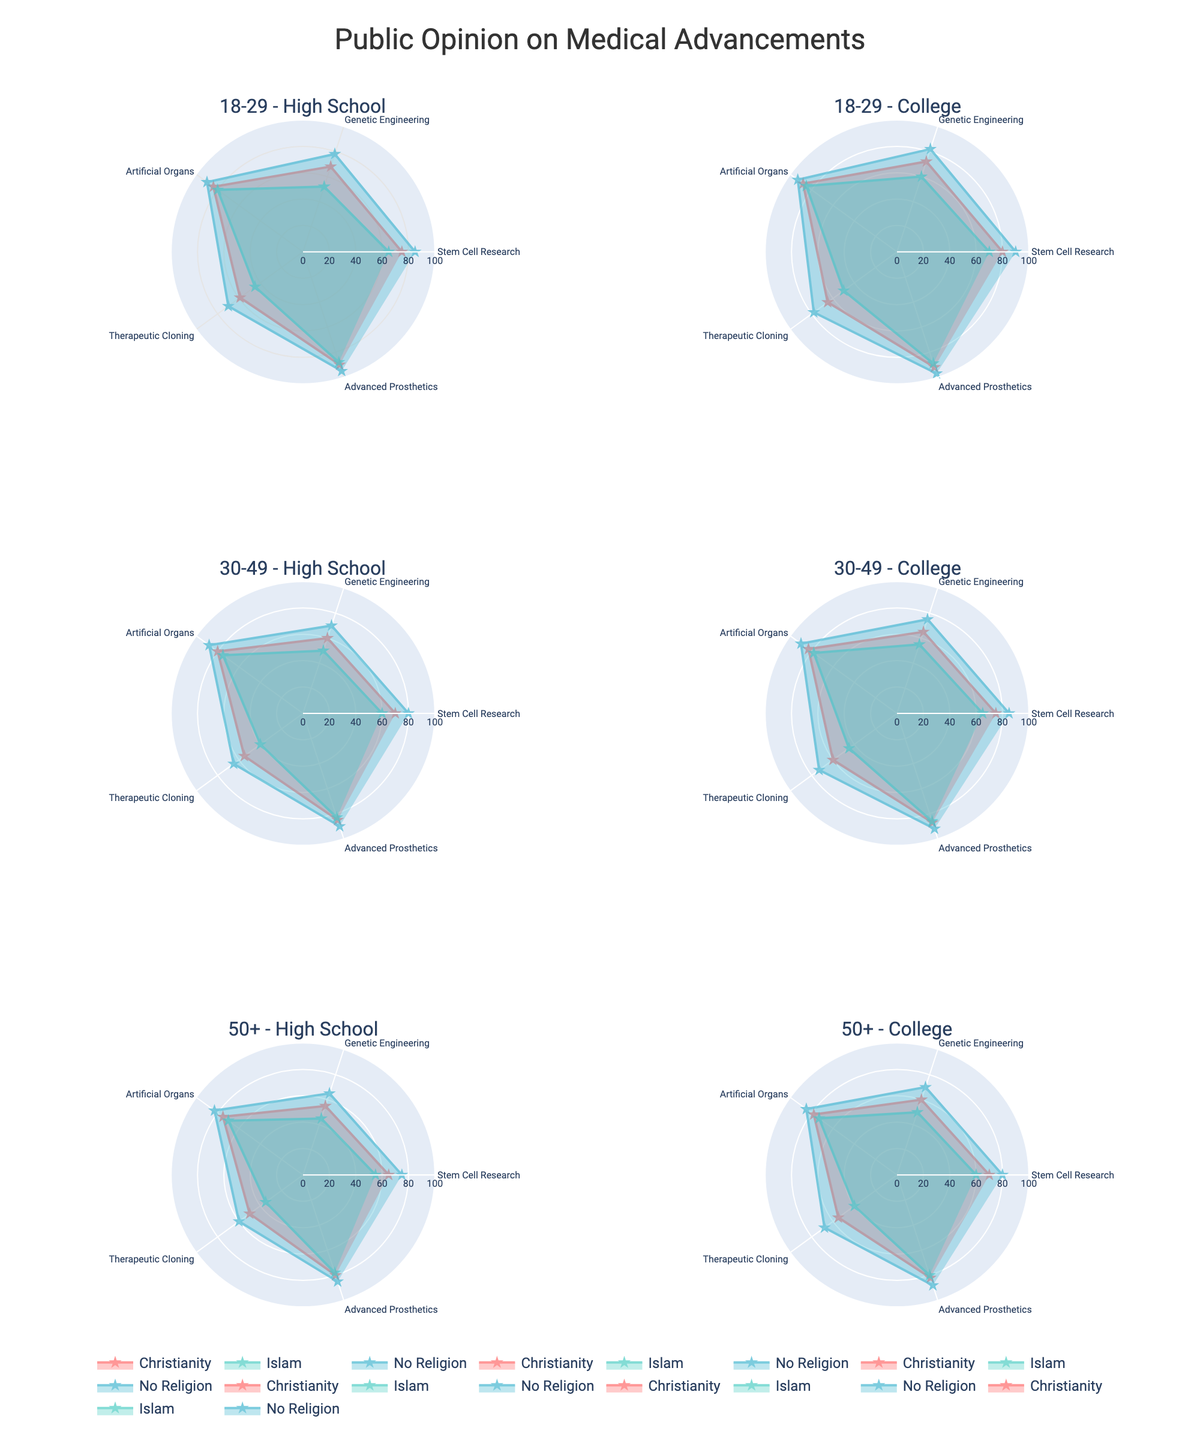Which age group and education level combination shows the highest support for advanced prosthetics across all religious beliefs? To determine this, look for the subplot with the largest values for advanced prosthetics in all religious belief categories. The subplot for the 18-29 age group with a college education shows the highest composite values across Christianity, Islam, and No Religion, indicating the highest support.
Answer: 18-29, College Which religious belief group consistently has the lowest support for therapeutic cloning across different age and education groups? Examine each subplot for therapeutic cloning support and identify which religious belief group has the lowest values. Across all subplots, the Islamic group consistently has the lowest support for therapeutic cloning.
Answer: Islam What is the average support for genetic engineering among the 18-29 age group with no religious affiliation? To find the average, locate the values for genetic engineering in the 18-29 age group with no religion in both high school and college subplots. The values are 78 (High School) and 82 (College). Therefore, the average is (78 + 82) / 2 = 80.
Answer: 80 How does the support for genetic engineering differ between the 50+ age group with a college education and no religion and the 18-29 age group with a college education and no religion? Compare the genetic engineering values for 50+ college-educated individuals without religion (70) and the 18-29 college-educated individuals without religion (82). The difference is 82 - 70 = 12.
Answer: 12 In which age group and education level combination is public opinion on stem cell research most uniform across different religious beliefs? To determine uniformity, look for the subplot where the stem cell research values are closest to each other across different religious beliefs. For the 50+ age group with a college education, the values for Christianity, Islam, and No Religion are 70, 60, and 80, respectively, showing close proximity to each other compared to other groups._
Answer: 50+, College Which medical advancement has the highest variation in support levels among the 30-49 age group with high school education? To assess the highest variation, look at the range of values (difference between highest and lowest) for each medical advancement within the 30-49 high school subplot. Advanced Prosthetics has values 85 (Christianity), 83 (Islam), and 90 (No Religion), so the variation is 90 - 83 = 7, which is the highest among the advancements.
Answer: Advanced Prosthetics Is there an age and education combination where support for all medical advancements is greater than 60 across all religious beliefs? Check the subplots for each age and education combination for values greater than 60 for all medical advancements. The 18-29 college-educated group has values greater than 60 for all medical advancements across Christianity, Islam, and No Religion.
Answer: 18-29, College 